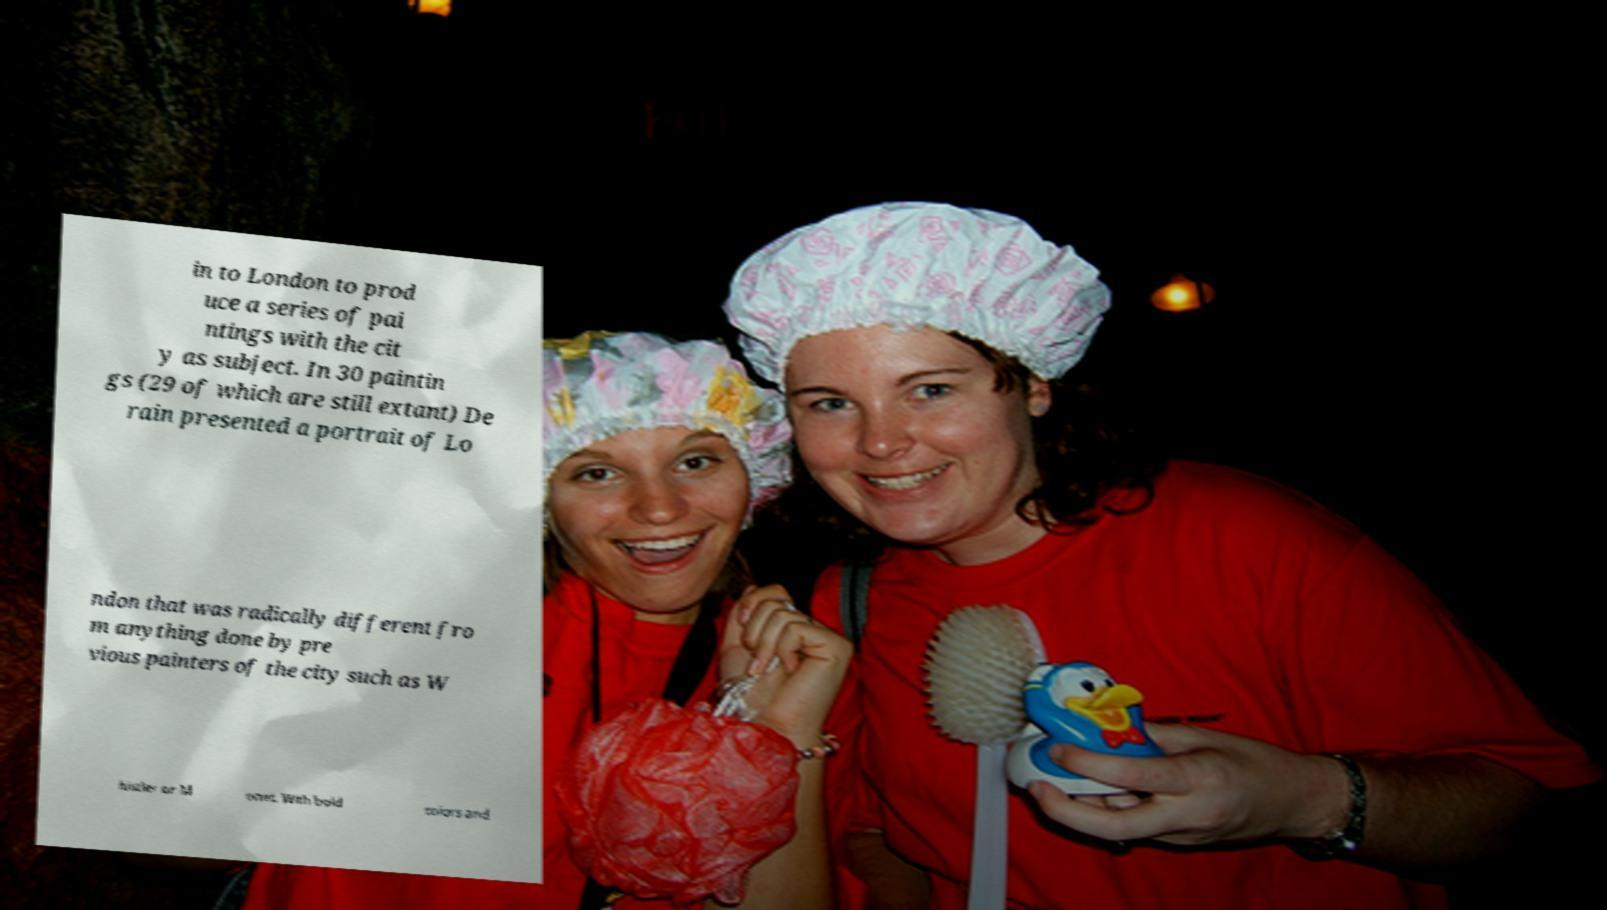Can you read and provide the text displayed in the image?This photo seems to have some interesting text. Can you extract and type it out for me? in to London to prod uce a series of pai ntings with the cit y as subject. In 30 paintin gs (29 of which are still extant) De rain presented a portrait of Lo ndon that was radically different fro m anything done by pre vious painters of the city such as W histler or M onet. With bold colors and 